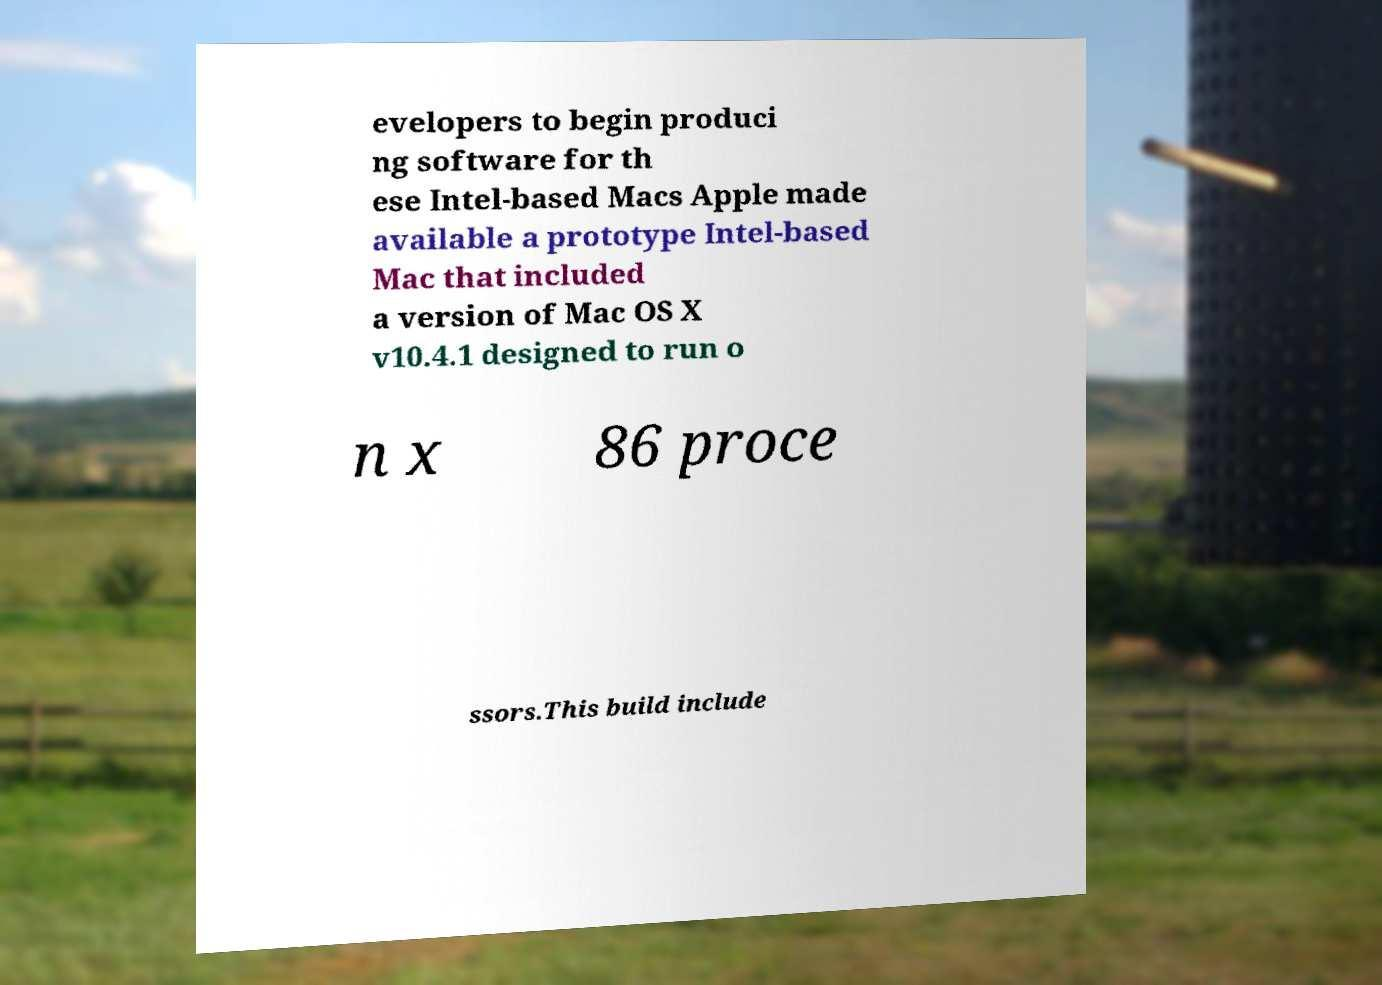For documentation purposes, I need the text within this image transcribed. Could you provide that? evelopers to begin produci ng software for th ese Intel-based Macs Apple made available a prototype Intel-based Mac that included a version of Mac OS X v10.4.1 designed to run o n x 86 proce ssors.This build include 